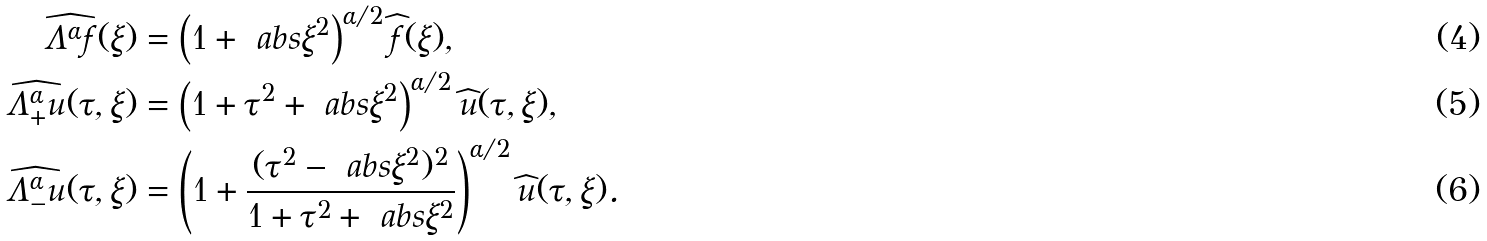<formula> <loc_0><loc_0><loc_500><loc_500>\widehat { \Lambda ^ { \alpha } f } ( \xi ) & = \left ( 1 + \ a b s { \xi } ^ { 2 } \right ) ^ { \alpha / 2 } \widehat { f } ( \xi ) , \\ \widehat { \Lambda _ { + } ^ { \alpha } u } ( \tau , \xi ) & = \left ( 1 + \tau ^ { 2 } + \ a b s { \xi } ^ { 2 } \right ) ^ { \alpha / 2 } \widehat { u } ( \tau , \xi ) , \\ \widehat { \Lambda _ { - } ^ { \alpha } u } ( \tau , \xi ) & = \left ( 1 + \frac { ( \tau ^ { 2 } - \ a b s { \xi } ^ { 2 } ) ^ { 2 } } { 1 + \tau ^ { 2 } + \ a b s { \xi } ^ { 2 } } \right ) ^ { \alpha / 2 } \widehat { u } ( \tau , \xi ) .</formula> 